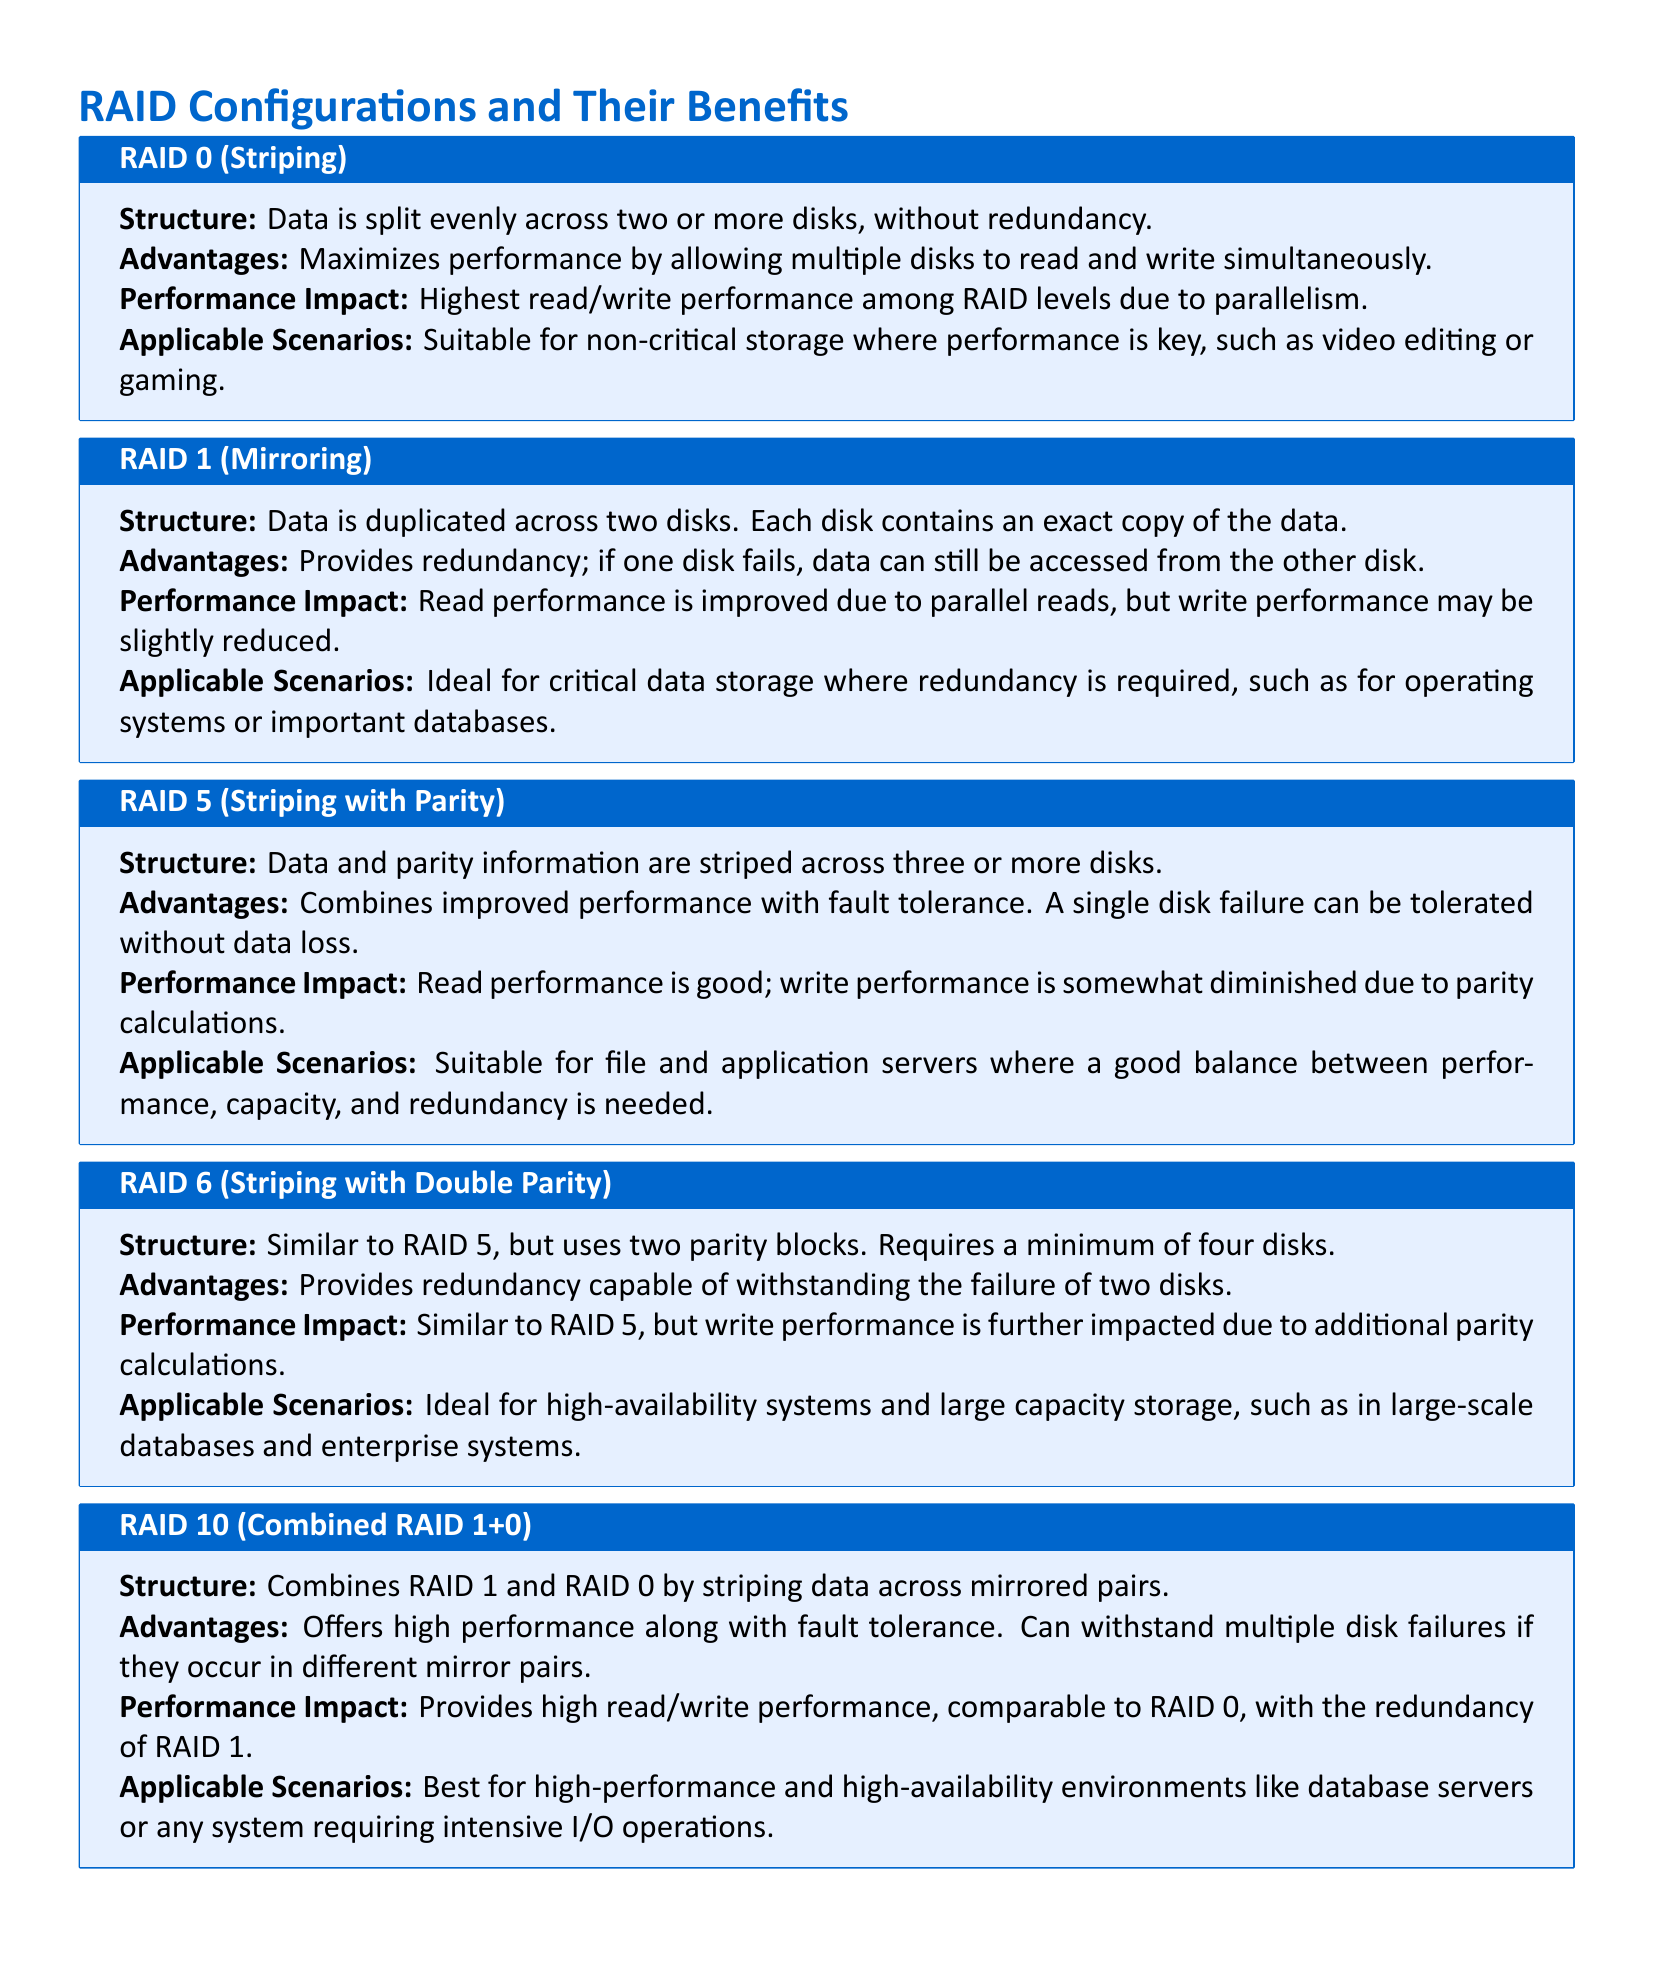What is RAID 0? RAID 0 is defined as data being split evenly across two or more disks, without redundancy.
Answer: Striping What minimum number of disks is required for RAID 6? RAID 6 requires a minimum of four disks to be implemented.
Answer: Four What is the primary advantage of RAID 1? The key advantage of RAID 1 is its ability to provide redundancy; if one disk fails, data can still be accessed from the other disk.
Answer: Redundancy How does RAID 10 combine other RAID levels? RAID 10 combines RAID 1 and RAID 0 by striping data across mirrored pairs.
Answer: Striping and Mirroring What is the performance impact of RAID 5 during writes? Write performance in RAID 5 is somewhat diminished due to parity calculations.
Answer: Diminished In which scenario is RAID 6 ideally applied? RAID 6 is ideal for high-availability systems and large capacity storage like large-scale databases.
Answer: High-availability systems What type of performance does RAID 0 offer? RAID 0 offers the highest read/write performance among RAID levels, due to parallelism.
Answer: Highest Which RAID configuration tolerates two disk failures? RAID 6 provides redundancy capable of withstanding the failure of two disks.
Answer: RAID 6 